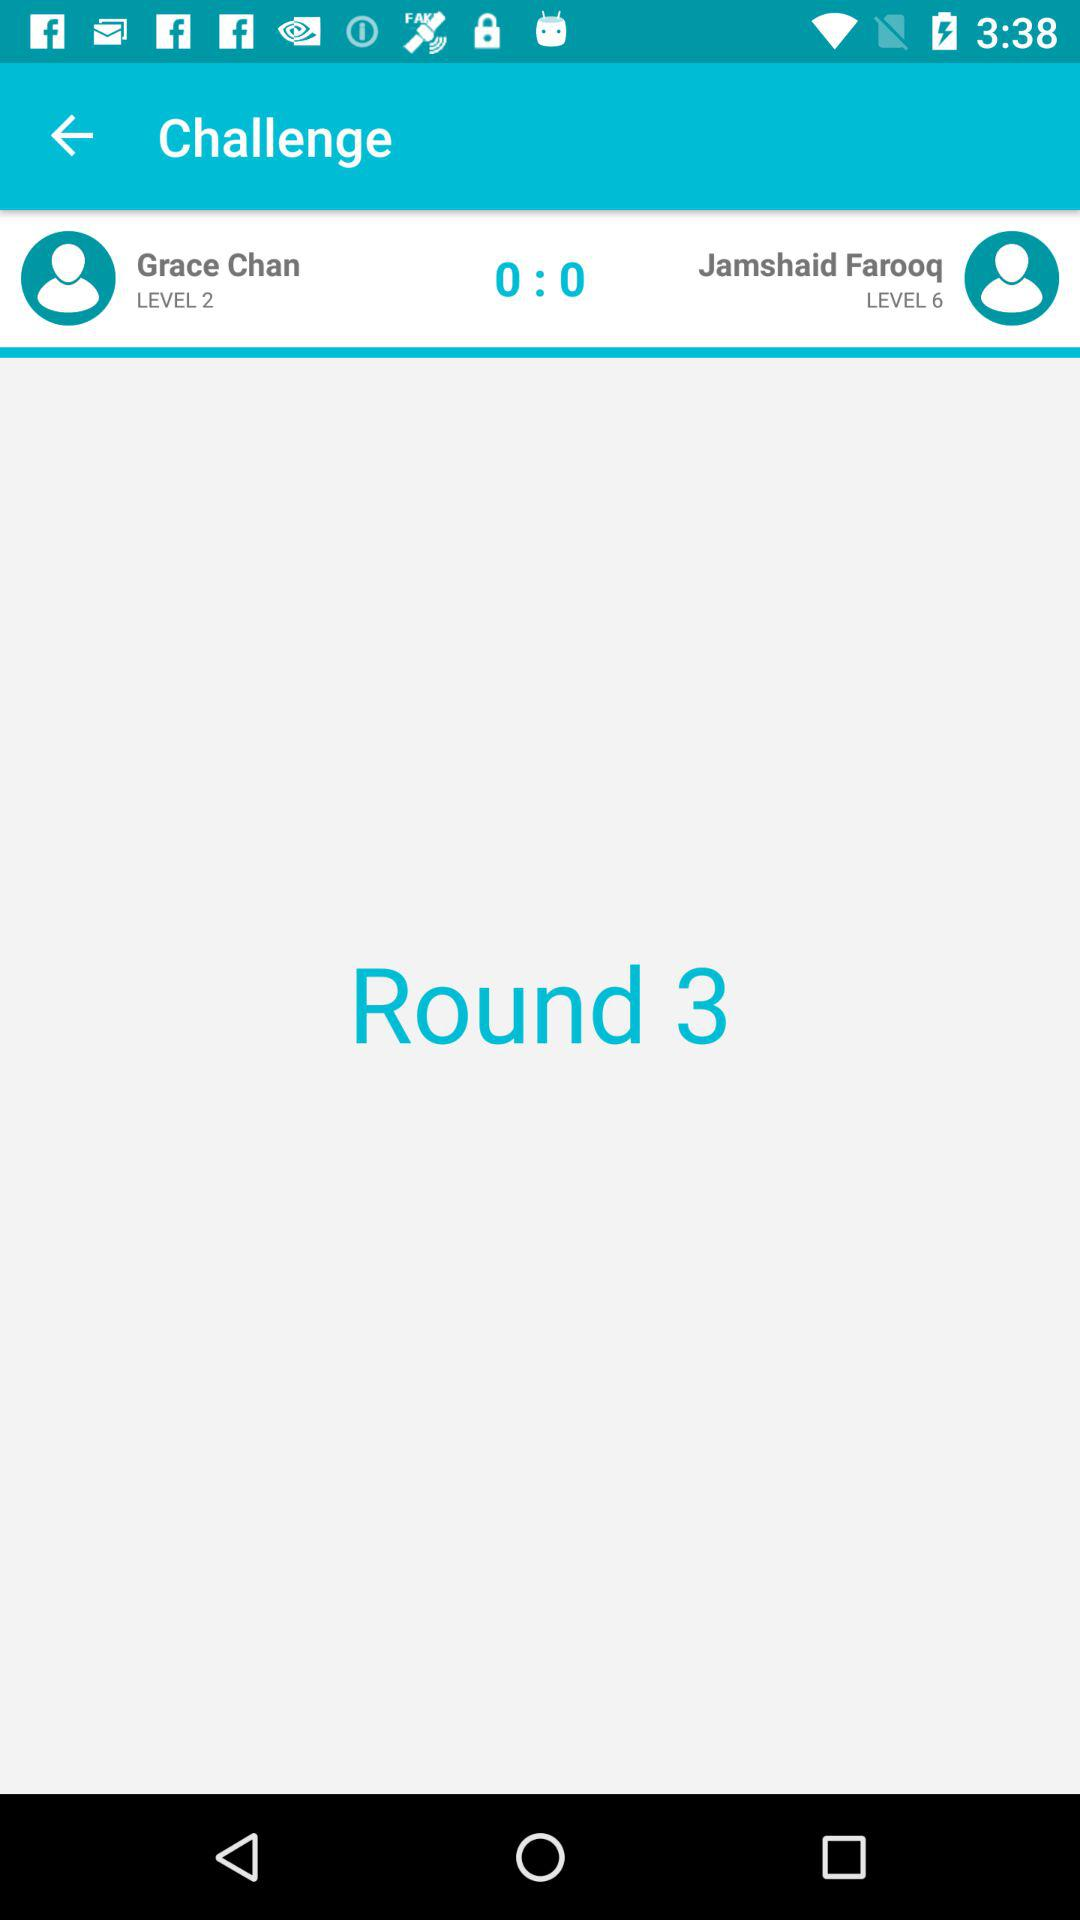What level is Jamshaid Farooq at? Jamshaid Farooq is at level 6. 